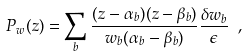<formula> <loc_0><loc_0><loc_500><loc_500>P _ { w } ( z ) = \sum _ { b } \frac { ( z - \alpha _ { b } ) ( z - \beta _ { b } ) } { w _ { b } ( \alpha _ { b } - \beta _ { b } ) } \frac { \delta w _ { b } } { \epsilon } \ ,</formula> 